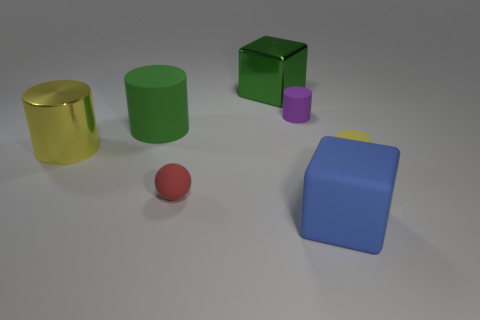Add 3 cyan objects. How many objects exist? 10 Subtract all shiny cylinders. How many cylinders are left? 3 Subtract 0 gray spheres. How many objects are left? 7 Subtract all cubes. How many objects are left? 5 Subtract 4 cylinders. How many cylinders are left? 0 Subtract all green balls. Subtract all brown cubes. How many balls are left? 1 Subtract all yellow cubes. How many brown cylinders are left? 0 Subtract all small yellow rubber balls. Subtract all balls. How many objects are left? 6 Add 6 purple rubber objects. How many purple rubber objects are left? 7 Add 1 small objects. How many small objects exist? 4 